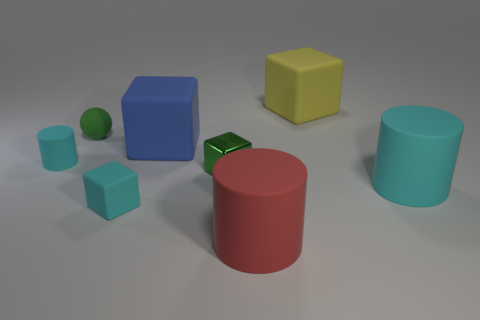Add 1 green blocks. How many objects exist? 9 Subtract all spheres. How many objects are left? 7 Add 6 small blocks. How many small blocks exist? 8 Subtract 0 brown balls. How many objects are left? 8 Subtract all tiny purple metal blocks. Subtract all cyan blocks. How many objects are left? 7 Add 2 matte things. How many matte things are left? 9 